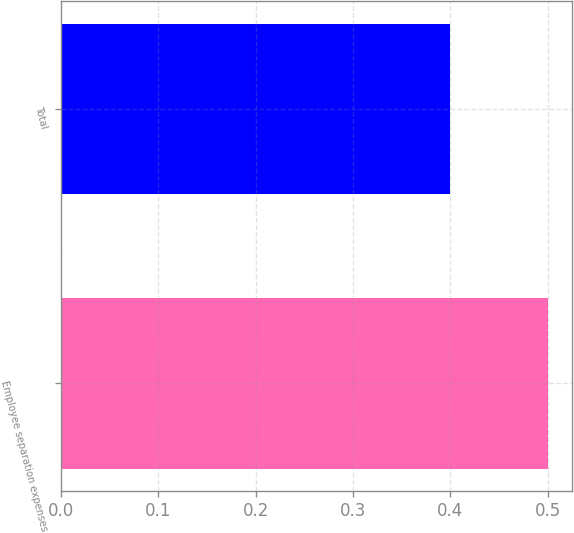<chart> <loc_0><loc_0><loc_500><loc_500><bar_chart><fcel>Employee separation expenses<fcel>Total<nl><fcel>0.5<fcel>0.4<nl></chart> 